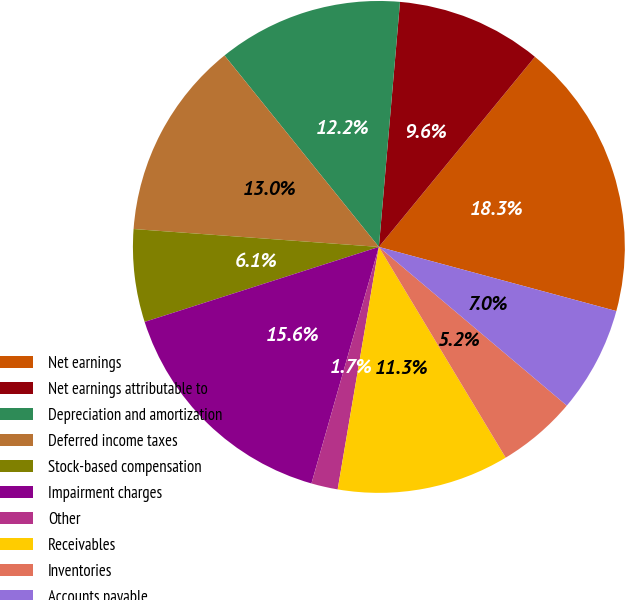Convert chart to OTSL. <chart><loc_0><loc_0><loc_500><loc_500><pie_chart><fcel>Net earnings<fcel>Net earnings attributable to<fcel>Depreciation and amortization<fcel>Deferred income taxes<fcel>Stock-based compensation<fcel>Impairment charges<fcel>Other<fcel>Receivables<fcel>Inventories<fcel>Accounts payable<nl><fcel>18.26%<fcel>9.57%<fcel>12.17%<fcel>13.04%<fcel>6.09%<fcel>15.65%<fcel>1.74%<fcel>11.3%<fcel>5.22%<fcel>6.96%<nl></chart> 